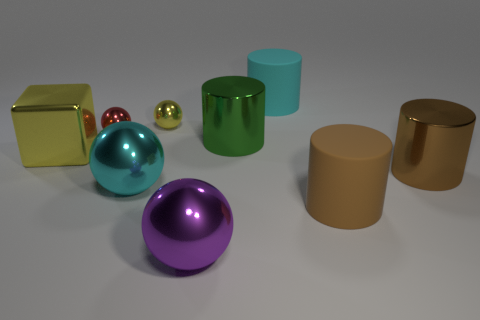Add 1 big brown objects. How many objects exist? 10 Subtract all cyan cylinders. How many cylinders are left? 3 Subtract all brown cubes. How many brown cylinders are left? 2 Subtract all red balls. How many balls are left? 3 Subtract 2 balls. How many balls are left? 2 Subtract all cylinders. How many objects are left? 5 Subtract all large brown objects. Subtract all large green things. How many objects are left? 6 Add 3 purple shiny objects. How many purple shiny objects are left? 4 Add 3 large blue matte blocks. How many large blue matte blocks exist? 3 Subtract 0 gray cylinders. How many objects are left? 9 